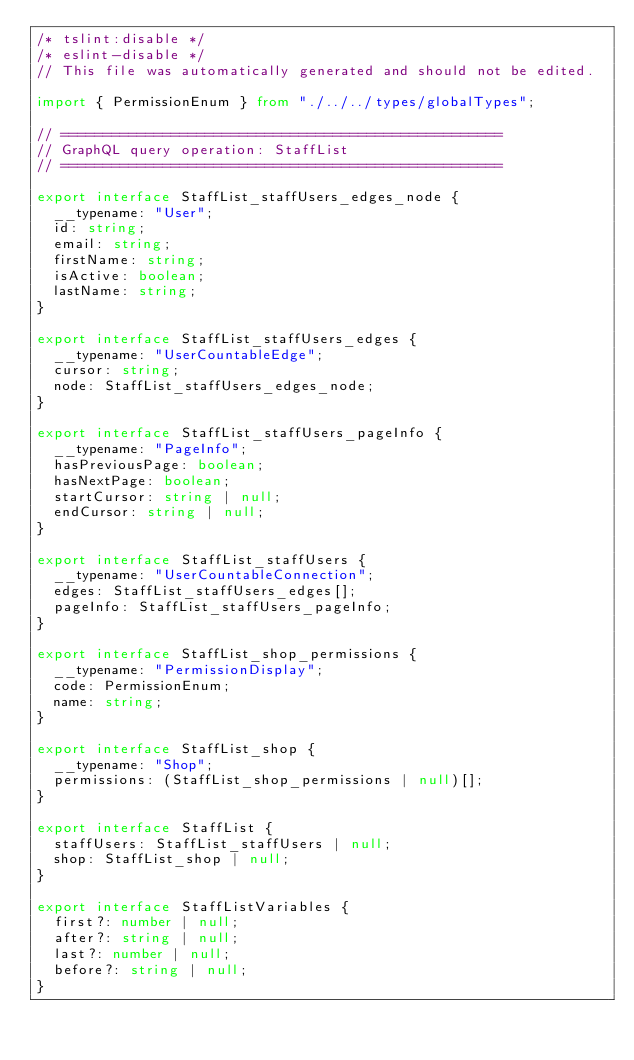<code> <loc_0><loc_0><loc_500><loc_500><_TypeScript_>/* tslint:disable */
/* eslint-disable */
// This file was automatically generated and should not be edited.

import { PermissionEnum } from "./../../types/globalTypes";

// ====================================================
// GraphQL query operation: StaffList
// ====================================================

export interface StaffList_staffUsers_edges_node {
  __typename: "User";
  id: string;
  email: string;
  firstName: string;
  isActive: boolean;
  lastName: string;
}

export interface StaffList_staffUsers_edges {
  __typename: "UserCountableEdge";
  cursor: string;
  node: StaffList_staffUsers_edges_node;
}

export interface StaffList_staffUsers_pageInfo {
  __typename: "PageInfo";
  hasPreviousPage: boolean;
  hasNextPage: boolean;
  startCursor: string | null;
  endCursor: string | null;
}

export interface StaffList_staffUsers {
  __typename: "UserCountableConnection";
  edges: StaffList_staffUsers_edges[];
  pageInfo: StaffList_staffUsers_pageInfo;
}

export interface StaffList_shop_permissions {
  __typename: "PermissionDisplay";
  code: PermissionEnum;
  name: string;
}

export interface StaffList_shop {
  __typename: "Shop";
  permissions: (StaffList_shop_permissions | null)[];
}

export interface StaffList {
  staffUsers: StaffList_staffUsers | null;
  shop: StaffList_shop | null;
}

export interface StaffListVariables {
  first?: number | null;
  after?: string | null;
  last?: number | null;
  before?: string | null;
}
</code> 